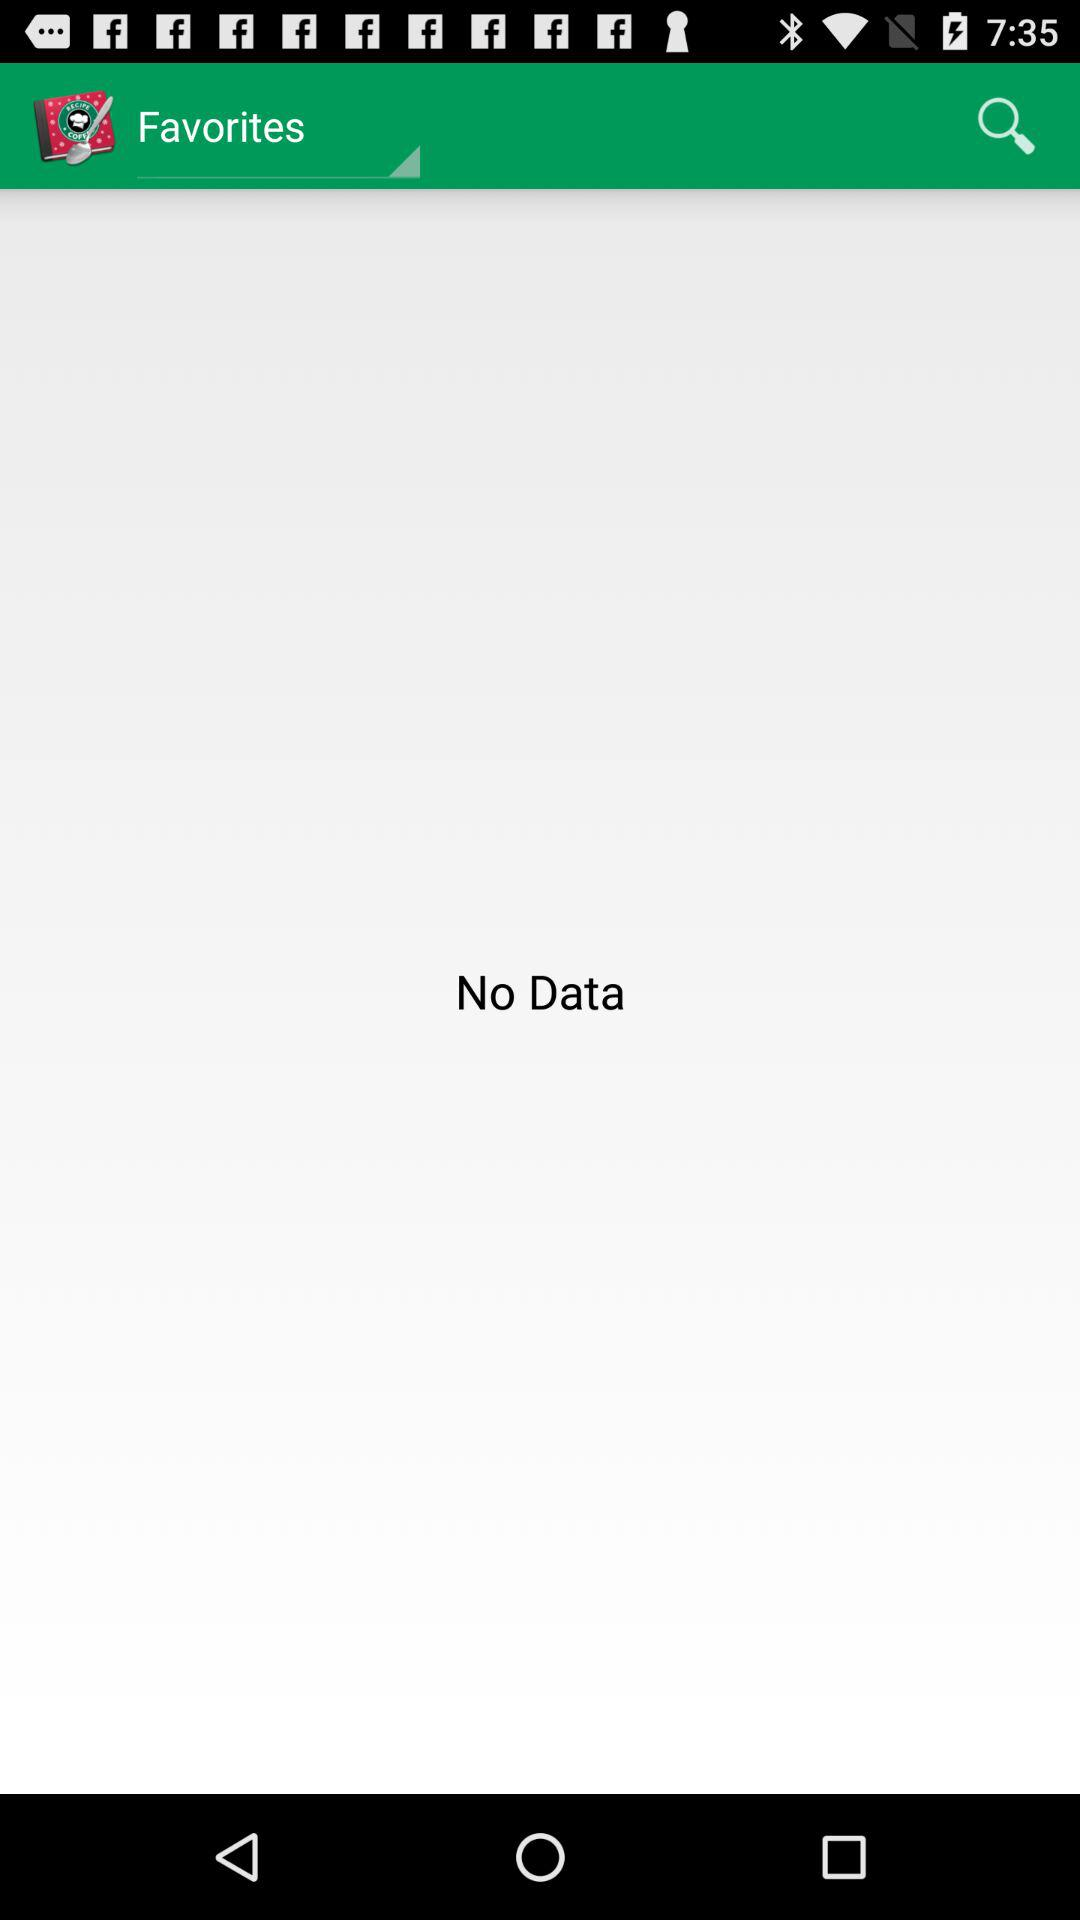Is there any data? There is no data. 